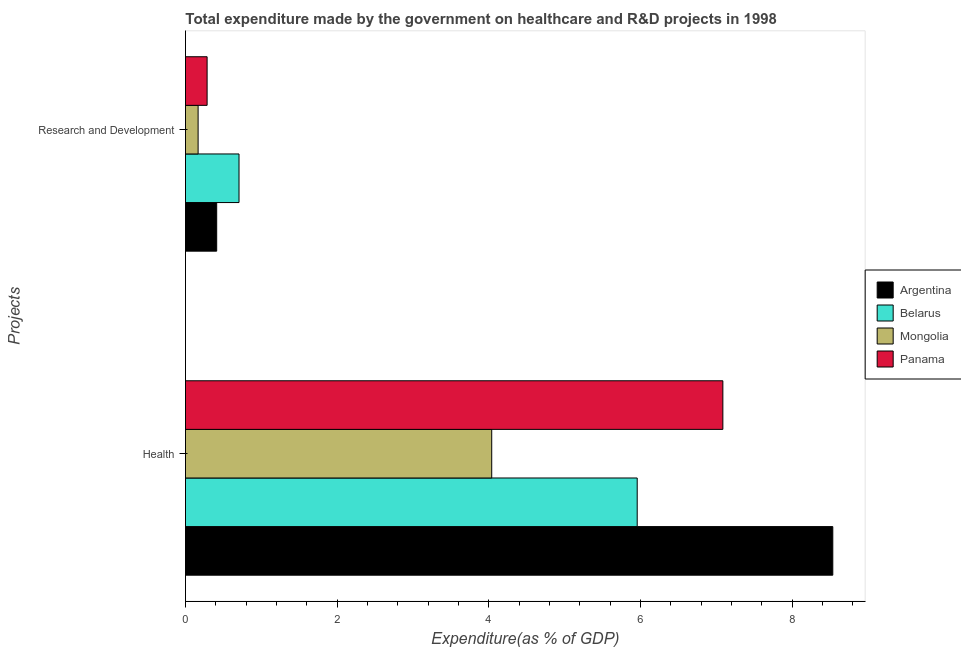How many different coloured bars are there?
Your response must be concise. 4. How many groups of bars are there?
Offer a terse response. 2. Are the number of bars per tick equal to the number of legend labels?
Your response must be concise. Yes. What is the label of the 1st group of bars from the top?
Offer a terse response. Research and Development. What is the expenditure in r&d in Belarus?
Provide a succinct answer. 0.71. Across all countries, what is the maximum expenditure in healthcare?
Provide a short and direct response. 8.54. Across all countries, what is the minimum expenditure in healthcare?
Keep it short and to the point. 4.04. In which country was the expenditure in r&d minimum?
Your answer should be very brief. Mongolia. What is the total expenditure in r&d in the graph?
Ensure brevity in your answer.  1.57. What is the difference between the expenditure in r&d in Argentina and that in Panama?
Offer a very short reply. 0.13. What is the difference between the expenditure in healthcare in Argentina and the expenditure in r&d in Panama?
Your answer should be very brief. 8.25. What is the average expenditure in healthcare per country?
Offer a terse response. 6.4. What is the difference between the expenditure in healthcare and expenditure in r&d in Panama?
Provide a short and direct response. 6.8. What is the ratio of the expenditure in r&d in Panama to that in Belarus?
Your answer should be very brief. 0.4. In how many countries, is the expenditure in r&d greater than the average expenditure in r&d taken over all countries?
Ensure brevity in your answer.  2. What does the 3rd bar from the top in Health represents?
Your response must be concise. Belarus. Are all the bars in the graph horizontal?
Your answer should be very brief. Yes. How many legend labels are there?
Give a very brief answer. 4. How are the legend labels stacked?
Offer a very short reply. Vertical. What is the title of the graph?
Provide a succinct answer. Total expenditure made by the government on healthcare and R&D projects in 1998. What is the label or title of the X-axis?
Provide a short and direct response. Expenditure(as % of GDP). What is the label or title of the Y-axis?
Keep it short and to the point. Projects. What is the Expenditure(as % of GDP) in Argentina in Health?
Provide a succinct answer. 8.54. What is the Expenditure(as % of GDP) in Belarus in Health?
Ensure brevity in your answer.  5.96. What is the Expenditure(as % of GDP) in Mongolia in Health?
Your response must be concise. 4.04. What is the Expenditure(as % of GDP) of Panama in Health?
Offer a very short reply. 7.09. What is the Expenditure(as % of GDP) in Argentina in Research and Development?
Keep it short and to the point. 0.41. What is the Expenditure(as % of GDP) in Belarus in Research and Development?
Your response must be concise. 0.71. What is the Expenditure(as % of GDP) of Mongolia in Research and Development?
Make the answer very short. 0.17. What is the Expenditure(as % of GDP) of Panama in Research and Development?
Make the answer very short. 0.29. Across all Projects, what is the maximum Expenditure(as % of GDP) of Argentina?
Your response must be concise. 8.54. Across all Projects, what is the maximum Expenditure(as % of GDP) in Belarus?
Your response must be concise. 5.96. Across all Projects, what is the maximum Expenditure(as % of GDP) in Mongolia?
Your answer should be very brief. 4.04. Across all Projects, what is the maximum Expenditure(as % of GDP) in Panama?
Make the answer very short. 7.09. Across all Projects, what is the minimum Expenditure(as % of GDP) in Argentina?
Provide a short and direct response. 0.41. Across all Projects, what is the minimum Expenditure(as % of GDP) of Belarus?
Your answer should be very brief. 0.71. Across all Projects, what is the minimum Expenditure(as % of GDP) of Mongolia?
Your response must be concise. 0.17. Across all Projects, what is the minimum Expenditure(as % of GDP) in Panama?
Your response must be concise. 0.29. What is the total Expenditure(as % of GDP) of Argentina in the graph?
Your answer should be very brief. 8.95. What is the total Expenditure(as % of GDP) of Belarus in the graph?
Offer a terse response. 6.66. What is the total Expenditure(as % of GDP) in Mongolia in the graph?
Provide a short and direct response. 4.2. What is the total Expenditure(as % of GDP) of Panama in the graph?
Your response must be concise. 7.37. What is the difference between the Expenditure(as % of GDP) in Argentina in Health and that in Research and Development?
Offer a terse response. 8.12. What is the difference between the Expenditure(as % of GDP) in Belarus in Health and that in Research and Development?
Provide a succinct answer. 5.25. What is the difference between the Expenditure(as % of GDP) in Mongolia in Health and that in Research and Development?
Your answer should be very brief. 3.87. What is the difference between the Expenditure(as % of GDP) in Panama in Health and that in Research and Development?
Provide a short and direct response. 6.8. What is the difference between the Expenditure(as % of GDP) in Argentina in Health and the Expenditure(as % of GDP) in Belarus in Research and Development?
Provide a succinct answer. 7.83. What is the difference between the Expenditure(as % of GDP) in Argentina in Health and the Expenditure(as % of GDP) in Mongolia in Research and Development?
Provide a short and direct response. 8.37. What is the difference between the Expenditure(as % of GDP) of Argentina in Health and the Expenditure(as % of GDP) of Panama in Research and Development?
Provide a short and direct response. 8.25. What is the difference between the Expenditure(as % of GDP) of Belarus in Health and the Expenditure(as % of GDP) of Mongolia in Research and Development?
Your answer should be compact. 5.79. What is the difference between the Expenditure(as % of GDP) in Belarus in Health and the Expenditure(as % of GDP) in Panama in Research and Development?
Your response must be concise. 5.67. What is the difference between the Expenditure(as % of GDP) in Mongolia in Health and the Expenditure(as % of GDP) in Panama in Research and Development?
Give a very brief answer. 3.75. What is the average Expenditure(as % of GDP) in Argentina per Projects?
Ensure brevity in your answer.  4.47. What is the average Expenditure(as % of GDP) in Belarus per Projects?
Provide a succinct answer. 3.33. What is the average Expenditure(as % of GDP) of Mongolia per Projects?
Ensure brevity in your answer.  2.1. What is the average Expenditure(as % of GDP) in Panama per Projects?
Give a very brief answer. 3.69. What is the difference between the Expenditure(as % of GDP) in Argentina and Expenditure(as % of GDP) in Belarus in Health?
Ensure brevity in your answer.  2.58. What is the difference between the Expenditure(as % of GDP) in Argentina and Expenditure(as % of GDP) in Mongolia in Health?
Your answer should be very brief. 4.5. What is the difference between the Expenditure(as % of GDP) in Argentina and Expenditure(as % of GDP) in Panama in Health?
Offer a terse response. 1.45. What is the difference between the Expenditure(as % of GDP) of Belarus and Expenditure(as % of GDP) of Mongolia in Health?
Give a very brief answer. 1.92. What is the difference between the Expenditure(as % of GDP) in Belarus and Expenditure(as % of GDP) in Panama in Health?
Provide a short and direct response. -1.13. What is the difference between the Expenditure(as % of GDP) in Mongolia and Expenditure(as % of GDP) in Panama in Health?
Offer a terse response. -3.05. What is the difference between the Expenditure(as % of GDP) in Argentina and Expenditure(as % of GDP) in Belarus in Research and Development?
Your response must be concise. -0.29. What is the difference between the Expenditure(as % of GDP) in Argentina and Expenditure(as % of GDP) in Mongolia in Research and Development?
Offer a very short reply. 0.24. What is the difference between the Expenditure(as % of GDP) in Argentina and Expenditure(as % of GDP) in Panama in Research and Development?
Offer a terse response. 0.13. What is the difference between the Expenditure(as % of GDP) in Belarus and Expenditure(as % of GDP) in Mongolia in Research and Development?
Your answer should be compact. 0.54. What is the difference between the Expenditure(as % of GDP) in Belarus and Expenditure(as % of GDP) in Panama in Research and Development?
Offer a terse response. 0.42. What is the difference between the Expenditure(as % of GDP) in Mongolia and Expenditure(as % of GDP) in Panama in Research and Development?
Your response must be concise. -0.12. What is the ratio of the Expenditure(as % of GDP) in Argentina in Health to that in Research and Development?
Your answer should be very brief. 20.75. What is the ratio of the Expenditure(as % of GDP) of Belarus in Health to that in Research and Development?
Your response must be concise. 8.44. What is the ratio of the Expenditure(as % of GDP) of Mongolia in Health to that in Research and Development?
Your answer should be very brief. 24.26. What is the ratio of the Expenditure(as % of GDP) in Panama in Health to that in Research and Development?
Your answer should be compact. 24.86. What is the difference between the highest and the second highest Expenditure(as % of GDP) of Argentina?
Ensure brevity in your answer.  8.12. What is the difference between the highest and the second highest Expenditure(as % of GDP) in Belarus?
Offer a very short reply. 5.25. What is the difference between the highest and the second highest Expenditure(as % of GDP) of Mongolia?
Your answer should be compact. 3.87. What is the difference between the highest and the second highest Expenditure(as % of GDP) of Panama?
Your answer should be compact. 6.8. What is the difference between the highest and the lowest Expenditure(as % of GDP) of Argentina?
Your answer should be compact. 8.12. What is the difference between the highest and the lowest Expenditure(as % of GDP) of Belarus?
Provide a succinct answer. 5.25. What is the difference between the highest and the lowest Expenditure(as % of GDP) in Mongolia?
Keep it short and to the point. 3.87. What is the difference between the highest and the lowest Expenditure(as % of GDP) in Panama?
Provide a short and direct response. 6.8. 